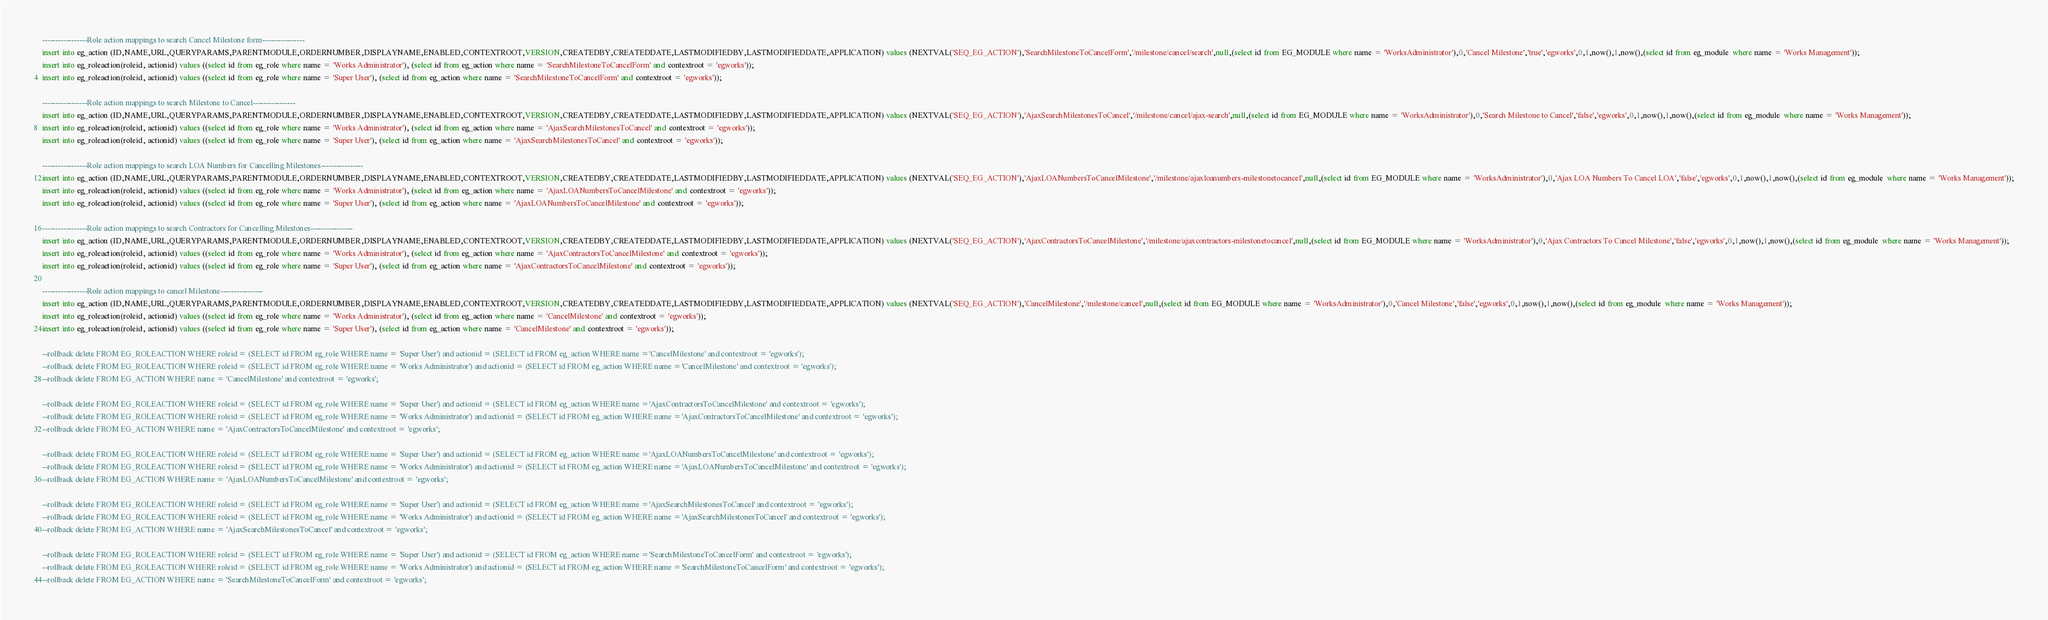<code> <loc_0><loc_0><loc_500><loc_500><_SQL_>-----------------Role action mappings to search Cancel Milestone form----------------
insert into eg_action (ID,NAME,URL,QUERYPARAMS,PARENTMODULE,ORDERNUMBER,DISPLAYNAME,ENABLED,CONTEXTROOT,VERSION,CREATEDBY,CREATEDDATE,LASTMODIFIEDBY,LASTMODIFIEDDATE,APPLICATION) values (NEXTVAL('SEQ_EG_ACTION'),'SearchMilestoneToCancelForm','/milestone/cancel/search',null,(select id from EG_MODULE where name = 'WorksAdministrator'),0,'Cancel Milestone','true','egworks',0,1,now(),1,now(),(select id from eg_module  where name = 'Works Management'));
insert into eg_roleaction(roleid, actionid) values ((select id from eg_role where name = 'Works Administrator'), (select id from eg_action where name = 'SearchMilestoneToCancelForm' and contextroot = 'egworks'));
insert into eg_roleaction(roleid, actionid) values ((select id from eg_role where name = 'Super User'), (select id from eg_action where name = 'SearchMilestoneToCancelForm' and contextroot = 'egworks'));

-----------------Role action mappings to search Milestone to Cancel----------------
insert into eg_action (ID,NAME,URL,QUERYPARAMS,PARENTMODULE,ORDERNUMBER,DISPLAYNAME,ENABLED,CONTEXTROOT,VERSION,CREATEDBY,CREATEDDATE,LASTMODIFIEDBY,LASTMODIFIEDDATE,APPLICATION) values (NEXTVAL('SEQ_EG_ACTION'),'AjaxSearchMilestonesToCancel','/milestone/cancel/ajax-search',null,(select id from EG_MODULE where name = 'WorksAdministrator'),0,'Search Milestone to Cancel','false','egworks',0,1,now(),1,now(),(select id from eg_module  where name = 'Works Management'));
insert into eg_roleaction(roleid, actionid) values ((select id from eg_role where name = 'Works Administrator'), (select id from eg_action where name = 'AjaxSearchMilestonesToCancel' and contextroot = 'egworks'));
insert into eg_roleaction(roleid, actionid) values ((select id from eg_role where name = 'Super User'), (select id from eg_action where name = 'AjaxSearchMilestonesToCancel' and contextroot = 'egworks'));

-----------------Role action mappings to search LOA Numbers for Cancelling Milestones----------------
insert into eg_action (ID,NAME,URL,QUERYPARAMS,PARENTMODULE,ORDERNUMBER,DISPLAYNAME,ENABLED,CONTEXTROOT,VERSION,CREATEDBY,CREATEDDATE,LASTMODIFIEDBY,LASTMODIFIEDDATE,APPLICATION) values (NEXTVAL('SEQ_EG_ACTION'),'AjaxLOANumbersToCancelMilestone','/milestone/ajaxloanumbers-milestonetocancel',null,(select id from EG_MODULE where name = 'WorksAdministrator'),0,'Ajax LOA Numbers To Cancel LOA','false','egworks',0,1,now(),1,now(),(select id from eg_module  where name = 'Works Management'));
insert into eg_roleaction(roleid, actionid) values ((select id from eg_role where name = 'Works Administrator'), (select id from eg_action where name = 'AjaxLOANumbersToCancelMilestone' and contextroot = 'egworks'));
insert into eg_roleaction(roleid, actionid) values ((select id from eg_role where name = 'Super User'), (select id from eg_action where name = 'AjaxLOANumbersToCancelMilestone' and contextroot = 'egworks'));

-----------------Role action mappings to search Contractors for Cancelling Milestones----------------
insert into eg_action (ID,NAME,URL,QUERYPARAMS,PARENTMODULE,ORDERNUMBER,DISPLAYNAME,ENABLED,CONTEXTROOT,VERSION,CREATEDBY,CREATEDDATE,LASTMODIFIEDBY,LASTMODIFIEDDATE,APPLICATION) values (NEXTVAL('SEQ_EG_ACTION'),'AjaxContractorsToCancelMilestone','/milestone/ajaxcontractors-milestonetocancel',null,(select id from EG_MODULE where name = 'WorksAdministrator'),0,'Ajax Contractors To Cancel Milestone','false','egworks',0,1,now(),1,now(),(select id from eg_module  where name = 'Works Management'));
insert into eg_roleaction(roleid, actionid) values ((select id from eg_role where name = 'Works Administrator'), (select id from eg_action where name = 'AjaxContractorsToCancelMilestone' and contextroot = 'egworks'));
insert into eg_roleaction(roleid, actionid) values ((select id from eg_role where name = 'Super User'), (select id from eg_action where name = 'AjaxContractorsToCancelMilestone' and contextroot = 'egworks'));

-----------------Role action mappings to cancel Milestone----------------
insert into eg_action (ID,NAME,URL,QUERYPARAMS,PARENTMODULE,ORDERNUMBER,DISPLAYNAME,ENABLED,CONTEXTROOT,VERSION,CREATEDBY,CREATEDDATE,LASTMODIFIEDBY,LASTMODIFIEDDATE,APPLICATION) values (NEXTVAL('SEQ_EG_ACTION'),'CancelMilestone','/milestone/cancel',null,(select id from EG_MODULE where name = 'WorksAdministrator'),0,'Cancel Milestone','false','egworks',0,1,now(),1,now(),(select id from eg_module  where name = 'Works Management'));
insert into eg_roleaction(roleid, actionid) values ((select id from eg_role where name = 'Works Administrator'), (select id from eg_action where name = 'CancelMilestone' and contextroot = 'egworks'));
insert into eg_roleaction(roleid, actionid) values ((select id from eg_role where name = 'Super User'), (select id from eg_action where name = 'CancelMilestone' and contextroot = 'egworks'));

--rollback delete FROM EG_ROLEACTION WHERE roleid = (SELECT id FROM eg_role WHERE name = 'Super User') and actionid = (SELECT id FROM eg_action WHERE name ='CancelMilestone' and contextroot = 'egworks');
--rollback delete FROM EG_ROLEACTION WHERE roleid = (SELECT id FROM eg_role WHERE name = 'Works Administrator') and actionid = (SELECT id FROM eg_action WHERE name ='CancelMilestone' and contextroot = 'egworks');
--rollback delete FROM EG_ACTION WHERE name = 'CancelMilestone' and contextroot = 'egworks';

--rollback delete FROM EG_ROLEACTION WHERE roleid = (SELECT id FROM eg_role WHERE name = 'Super User') and actionid = (SELECT id FROM eg_action WHERE name ='AjaxContractorsToCancelMilestone' and contextroot = 'egworks');
--rollback delete FROM EG_ROLEACTION WHERE roleid = (SELECT id FROM eg_role WHERE name = 'Works Administrator') and actionid = (SELECT id FROM eg_action WHERE name ='AjaxContractorsToCancelMilestone' and contextroot = 'egworks');
--rollback delete FROM EG_ACTION WHERE name = 'AjaxContractorsToCancelMilestone' and contextroot = 'egworks';

--rollback delete FROM EG_ROLEACTION WHERE roleid = (SELECT id FROM eg_role WHERE name = 'Super User') and actionid = (SELECT id FROM eg_action WHERE name ='AjaxLOANumbersToCancelMilestone' and contextroot = 'egworks');
--rollback delete FROM EG_ROLEACTION WHERE roleid = (SELECT id FROM eg_role WHERE name = 'Works Administrator') and actionid = (SELECT id FROM eg_action WHERE name ='AjaxLOANumbersToCancelMilestone' and contextroot = 'egworks');
--rollback delete FROM EG_ACTION WHERE name = 'AjaxLOANumbersToCancelMilestone' and contextroot = 'egworks';

--rollback delete FROM EG_ROLEACTION WHERE roleid = (SELECT id FROM eg_role WHERE name = 'Super User') and actionid = (SELECT id FROM eg_action WHERE name ='AjaxSearchMilestonesToCancel' and contextroot = 'egworks');
--rollback delete FROM EG_ROLEACTION WHERE roleid = (SELECT id FROM eg_role WHERE name = 'Works Administrator') and actionid = (SELECT id FROM eg_action WHERE name ='AjaxSearchMilestonesToCancel' and contextroot = 'egworks');
--rollback delete FROM EG_ACTION WHERE name = 'AjaxSearchMilestonesToCancel' and contextroot = 'egworks';

--rollback delete FROM EG_ROLEACTION WHERE roleid = (SELECT id FROM eg_role WHERE name = 'Super User') and actionid = (SELECT id FROM eg_action WHERE name ='SearchMilestoneToCancelForm' and contextroot = 'egworks');
--rollback delete FROM EG_ROLEACTION WHERE roleid = (SELECT id FROM eg_role WHERE name = 'Works Administrator') and actionid = (SELECT id FROM eg_action WHERE name ='SearchMilestoneToCancelForm' and contextroot = 'egworks');
--rollback delete FROM EG_ACTION WHERE name = 'SearchMilestoneToCancelForm' and contextroot = 'egworks';</code> 